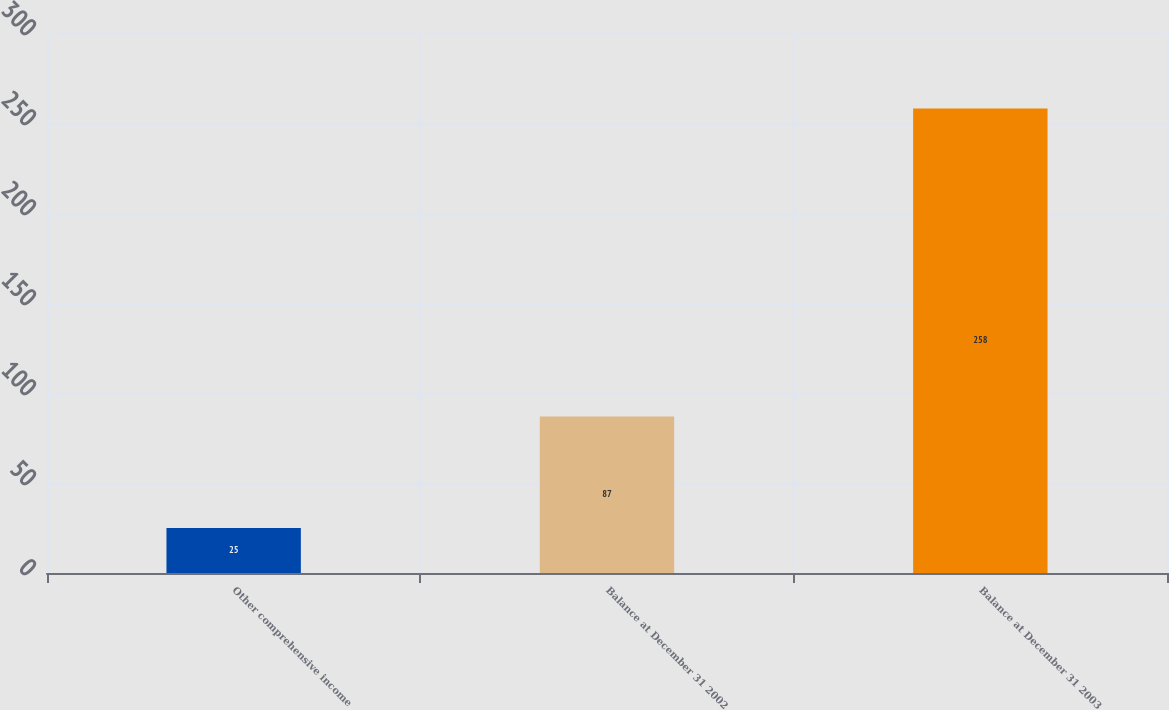Convert chart to OTSL. <chart><loc_0><loc_0><loc_500><loc_500><bar_chart><fcel>Other comprehensive income<fcel>Balance at December 31 2002<fcel>Balance at December 31 2003<nl><fcel>25<fcel>87<fcel>258<nl></chart> 